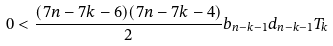<formula> <loc_0><loc_0><loc_500><loc_500>0 < \frac { ( 7 n - 7 k - 6 ) ( 7 n - 7 k - 4 ) } { 2 } b _ { n - k - 1 } d _ { n - k - 1 } T _ { k }</formula> 